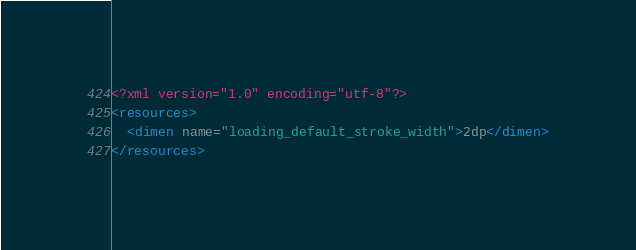Convert code to text. <code><loc_0><loc_0><loc_500><loc_500><_XML_><?xml version="1.0" encoding="utf-8"?>
<resources>
  <dimen name="loading_default_stroke_width">2dp</dimen>
</resources></code> 